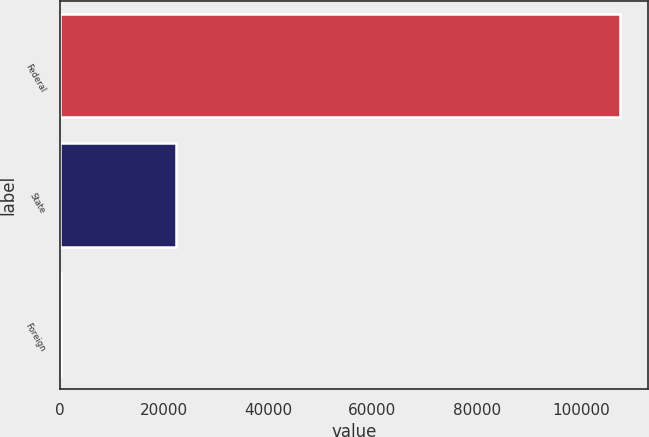Convert chart to OTSL. <chart><loc_0><loc_0><loc_500><loc_500><bar_chart><fcel>Federal<fcel>State<fcel>Foreign<nl><fcel>107503<fcel>22332<fcel>309<nl></chart> 